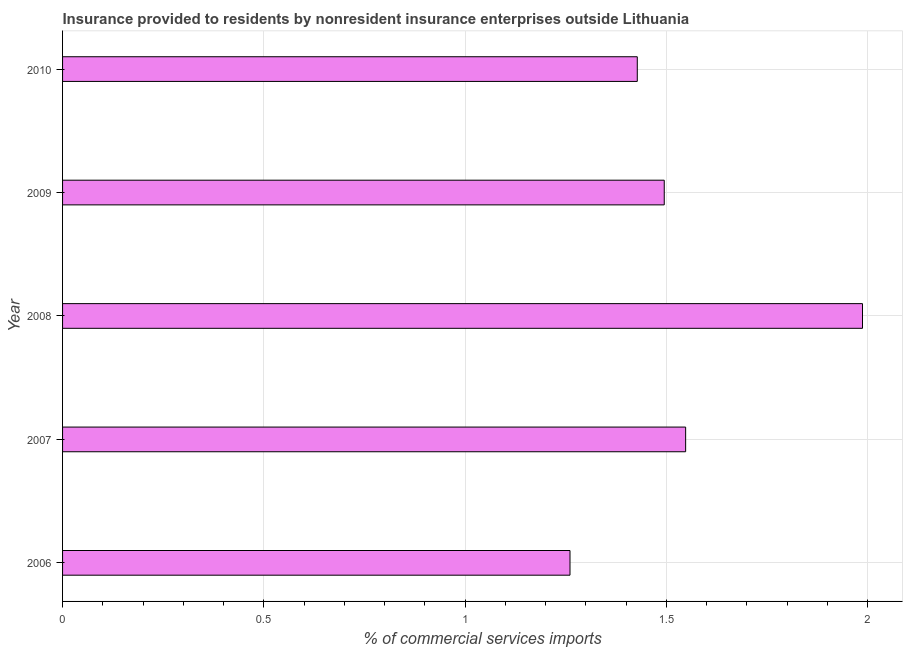Does the graph contain any zero values?
Make the answer very short. No. Does the graph contain grids?
Offer a terse response. Yes. What is the title of the graph?
Give a very brief answer. Insurance provided to residents by nonresident insurance enterprises outside Lithuania. What is the label or title of the X-axis?
Keep it short and to the point. % of commercial services imports. What is the label or title of the Y-axis?
Offer a terse response. Year. What is the insurance provided by non-residents in 2008?
Your answer should be very brief. 1.99. Across all years, what is the maximum insurance provided by non-residents?
Make the answer very short. 1.99. Across all years, what is the minimum insurance provided by non-residents?
Give a very brief answer. 1.26. In which year was the insurance provided by non-residents maximum?
Give a very brief answer. 2008. In which year was the insurance provided by non-residents minimum?
Your answer should be compact. 2006. What is the sum of the insurance provided by non-residents?
Offer a very short reply. 7.72. What is the difference between the insurance provided by non-residents in 2008 and 2010?
Provide a short and direct response. 0.56. What is the average insurance provided by non-residents per year?
Your answer should be very brief. 1.54. What is the median insurance provided by non-residents?
Offer a very short reply. 1.49. In how many years, is the insurance provided by non-residents greater than 1.5 %?
Offer a very short reply. 2. Do a majority of the years between 2009 and 2007 (inclusive) have insurance provided by non-residents greater than 0.8 %?
Your answer should be very brief. Yes. What is the ratio of the insurance provided by non-residents in 2008 to that in 2009?
Your answer should be very brief. 1.33. Is the insurance provided by non-residents in 2007 less than that in 2010?
Keep it short and to the point. No. Is the difference between the insurance provided by non-residents in 2006 and 2007 greater than the difference between any two years?
Your response must be concise. No. What is the difference between the highest and the second highest insurance provided by non-residents?
Your answer should be compact. 0.44. Is the sum of the insurance provided by non-residents in 2009 and 2010 greater than the maximum insurance provided by non-residents across all years?
Provide a short and direct response. Yes. What is the difference between the highest and the lowest insurance provided by non-residents?
Provide a short and direct response. 0.73. Are all the bars in the graph horizontal?
Your response must be concise. Yes. What is the difference between two consecutive major ticks on the X-axis?
Keep it short and to the point. 0.5. What is the % of commercial services imports in 2006?
Your response must be concise. 1.26. What is the % of commercial services imports in 2007?
Your answer should be very brief. 1.55. What is the % of commercial services imports in 2008?
Provide a succinct answer. 1.99. What is the % of commercial services imports in 2009?
Provide a short and direct response. 1.49. What is the % of commercial services imports of 2010?
Give a very brief answer. 1.43. What is the difference between the % of commercial services imports in 2006 and 2007?
Your answer should be very brief. -0.29. What is the difference between the % of commercial services imports in 2006 and 2008?
Give a very brief answer. -0.73. What is the difference between the % of commercial services imports in 2006 and 2009?
Your response must be concise. -0.23. What is the difference between the % of commercial services imports in 2006 and 2010?
Offer a very short reply. -0.17. What is the difference between the % of commercial services imports in 2007 and 2008?
Offer a terse response. -0.44. What is the difference between the % of commercial services imports in 2007 and 2009?
Your answer should be compact. 0.05. What is the difference between the % of commercial services imports in 2007 and 2010?
Make the answer very short. 0.12. What is the difference between the % of commercial services imports in 2008 and 2009?
Make the answer very short. 0.49. What is the difference between the % of commercial services imports in 2008 and 2010?
Your answer should be compact. 0.56. What is the difference between the % of commercial services imports in 2009 and 2010?
Provide a short and direct response. 0.07. What is the ratio of the % of commercial services imports in 2006 to that in 2007?
Your answer should be very brief. 0.81. What is the ratio of the % of commercial services imports in 2006 to that in 2008?
Your response must be concise. 0.63. What is the ratio of the % of commercial services imports in 2006 to that in 2009?
Make the answer very short. 0.84. What is the ratio of the % of commercial services imports in 2006 to that in 2010?
Offer a very short reply. 0.88. What is the ratio of the % of commercial services imports in 2007 to that in 2008?
Your answer should be compact. 0.78. What is the ratio of the % of commercial services imports in 2007 to that in 2009?
Ensure brevity in your answer.  1.04. What is the ratio of the % of commercial services imports in 2007 to that in 2010?
Offer a very short reply. 1.08. What is the ratio of the % of commercial services imports in 2008 to that in 2009?
Ensure brevity in your answer.  1.33. What is the ratio of the % of commercial services imports in 2008 to that in 2010?
Keep it short and to the point. 1.39. What is the ratio of the % of commercial services imports in 2009 to that in 2010?
Your answer should be compact. 1.05. 